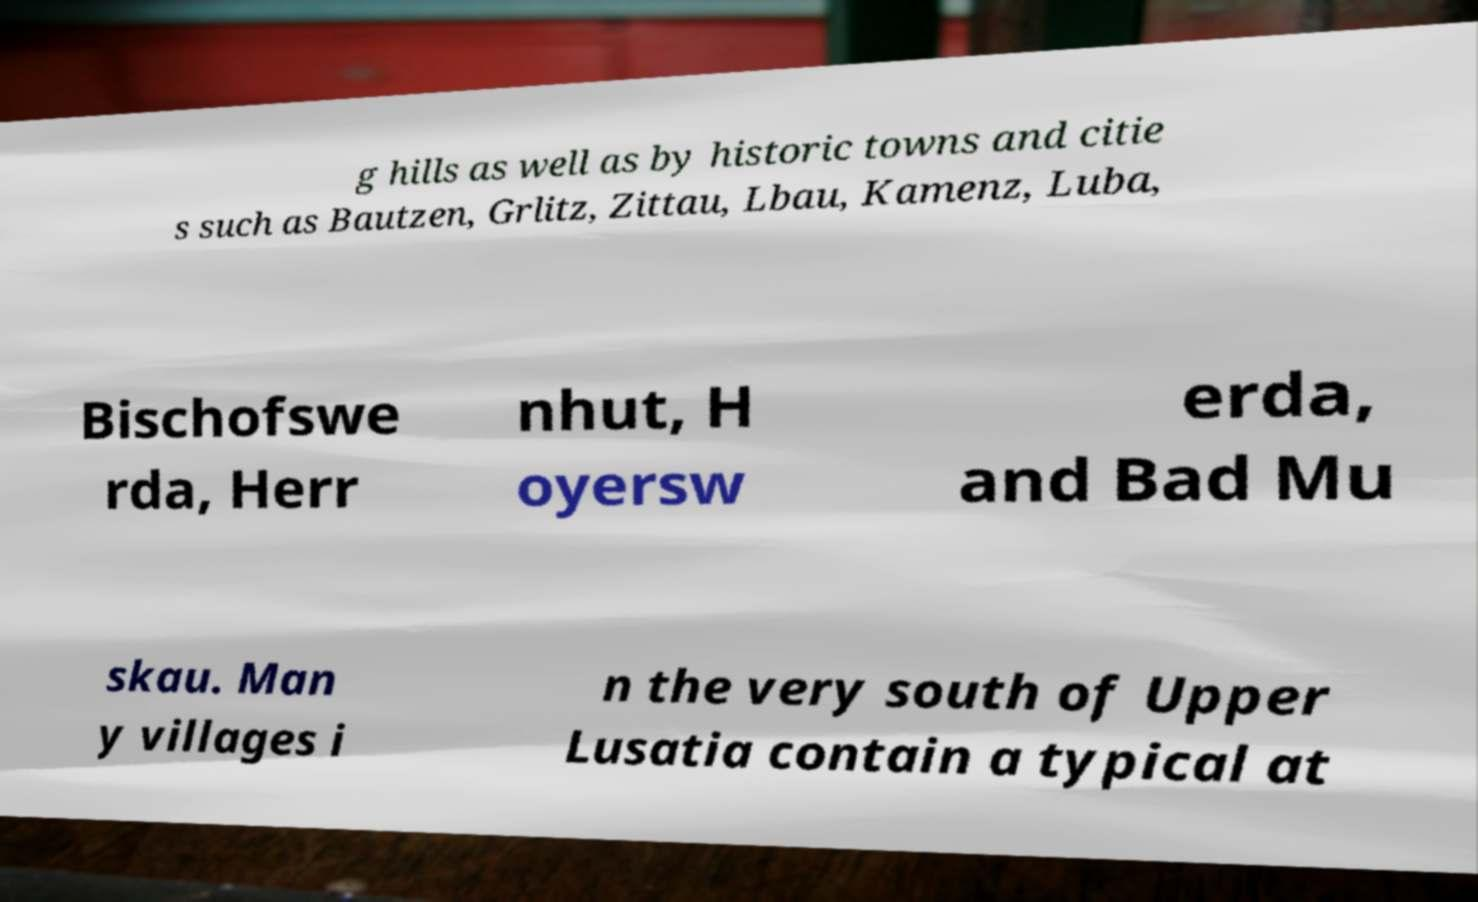Please identify and transcribe the text found in this image. g hills as well as by historic towns and citie s such as Bautzen, Grlitz, Zittau, Lbau, Kamenz, Luba, Bischofswe rda, Herr nhut, H oyersw erda, and Bad Mu skau. Man y villages i n the very south of Upper Lusatia contain a typical at 